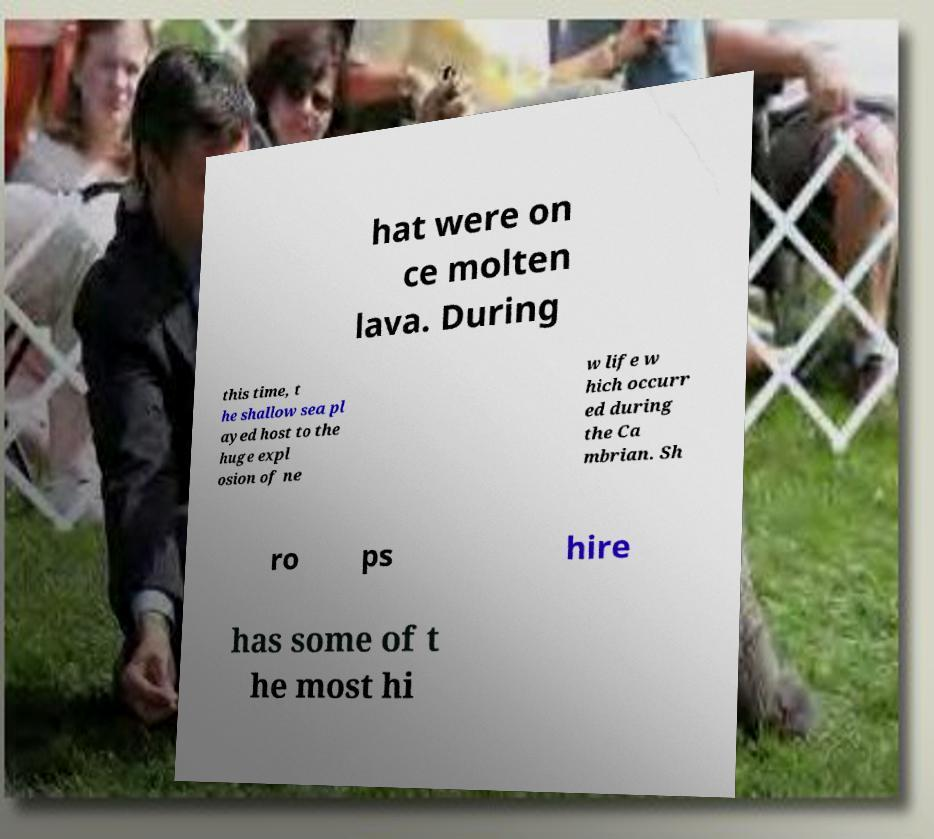Can you read and provide the text displayed in the image?This photo seems to have some interesting text. Can you extract and type it out for me? hat were on ce molten lava. During this time, t he shallow sea pl ayed host to the huge expl osion of ne w life w hich occurr ed during the Ca mbrian. Sh ro ps hire has some of t he most hi 